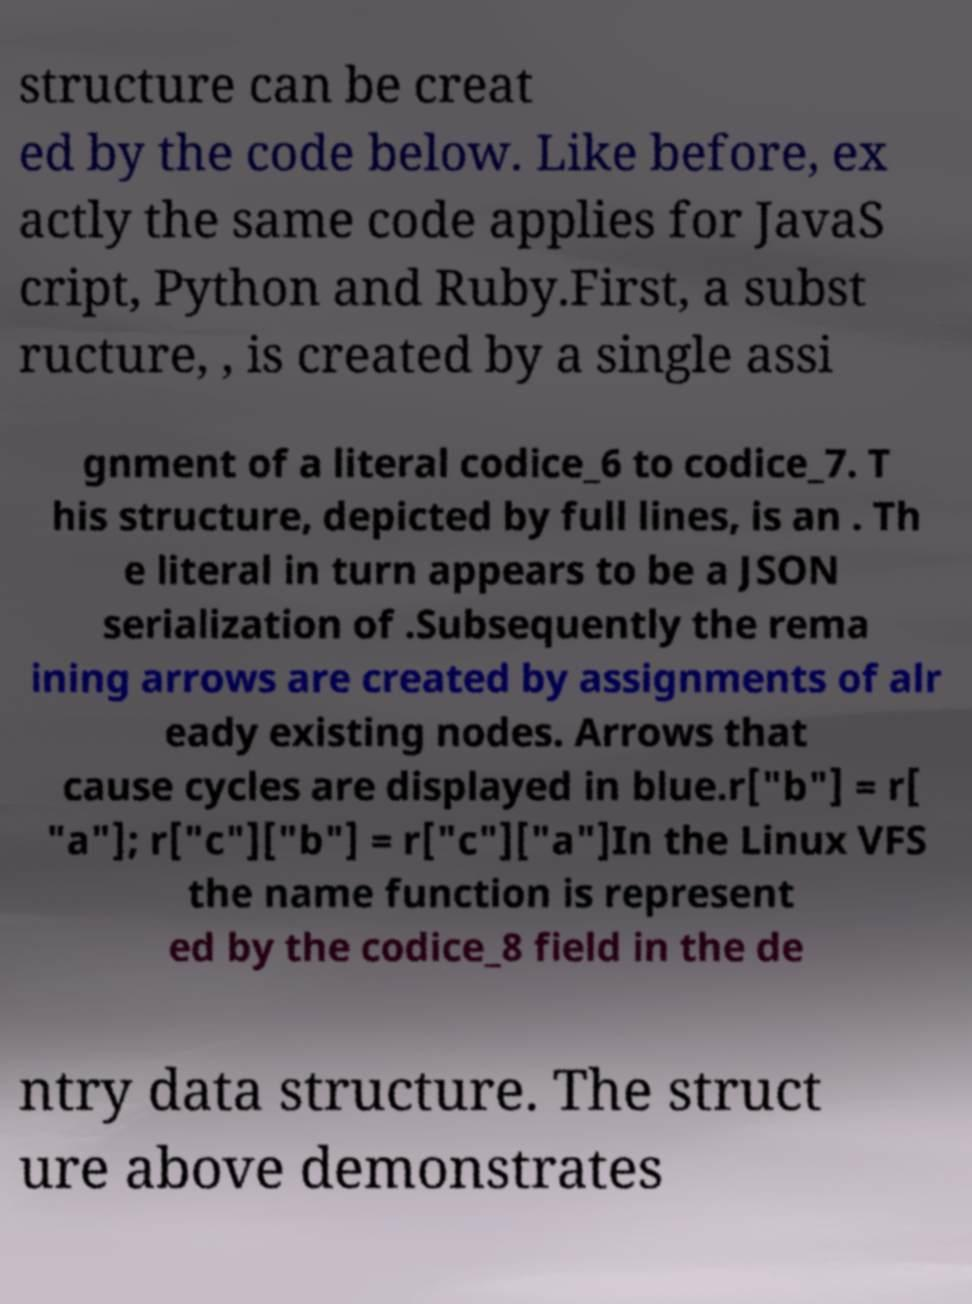Please read and relay the text visible in this image. What does it say? structure can be creat ed by the code below. Like before, ex actly the same code applies for JavaS cript, Python and Ruby.First, a subst ructure, , is created by a single assi gnment of a literal codice_6 to codice_7. T his structure, depicted by full lines, is an . Th e literal in turn appears to be a JSON serialization of .Subsequently the rema ining arrows are created by assignments of alr eady existing nodes. Arrows that cause cycles are displayed in blue.r["b"] = r[ "a"]; r["c"]["b"] = r["c"]["a"]In the Linux VFS the name function is represent ed by the codice_8 field in the de ntry data structure. The struct ure above demonstrates 